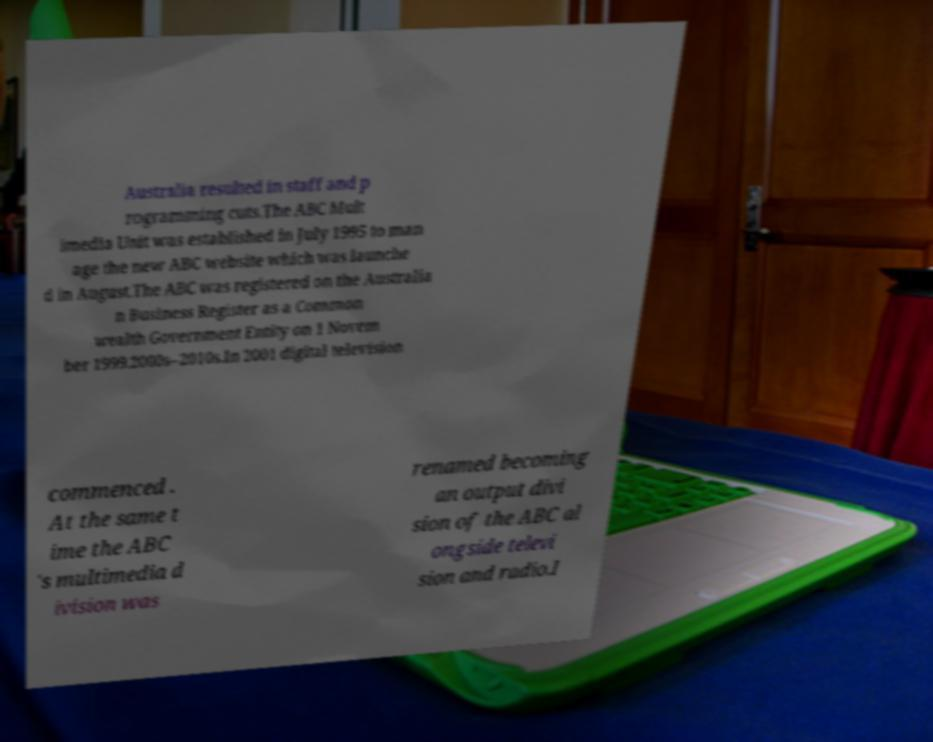Can you read and provide the text displayed in the image?This photo seems to have some interesting text. Can you extract and type it out for me? Australia resulted in staff and p rogramming cuts.The ABC Mult imedia Unit was established in July 1995 to man age the new ABC website which was launche d in August.The ABC was registered on the Australia n Business Register as a Common wealth Government Entity on 1 Novem ber 1999.2000s–2010s.In 2001 digital television commenced . At the same t ime the ABC 's multimedia d ivision was renamed becoming an output divi sion of the ABC al ongside televi sion and radio.I 